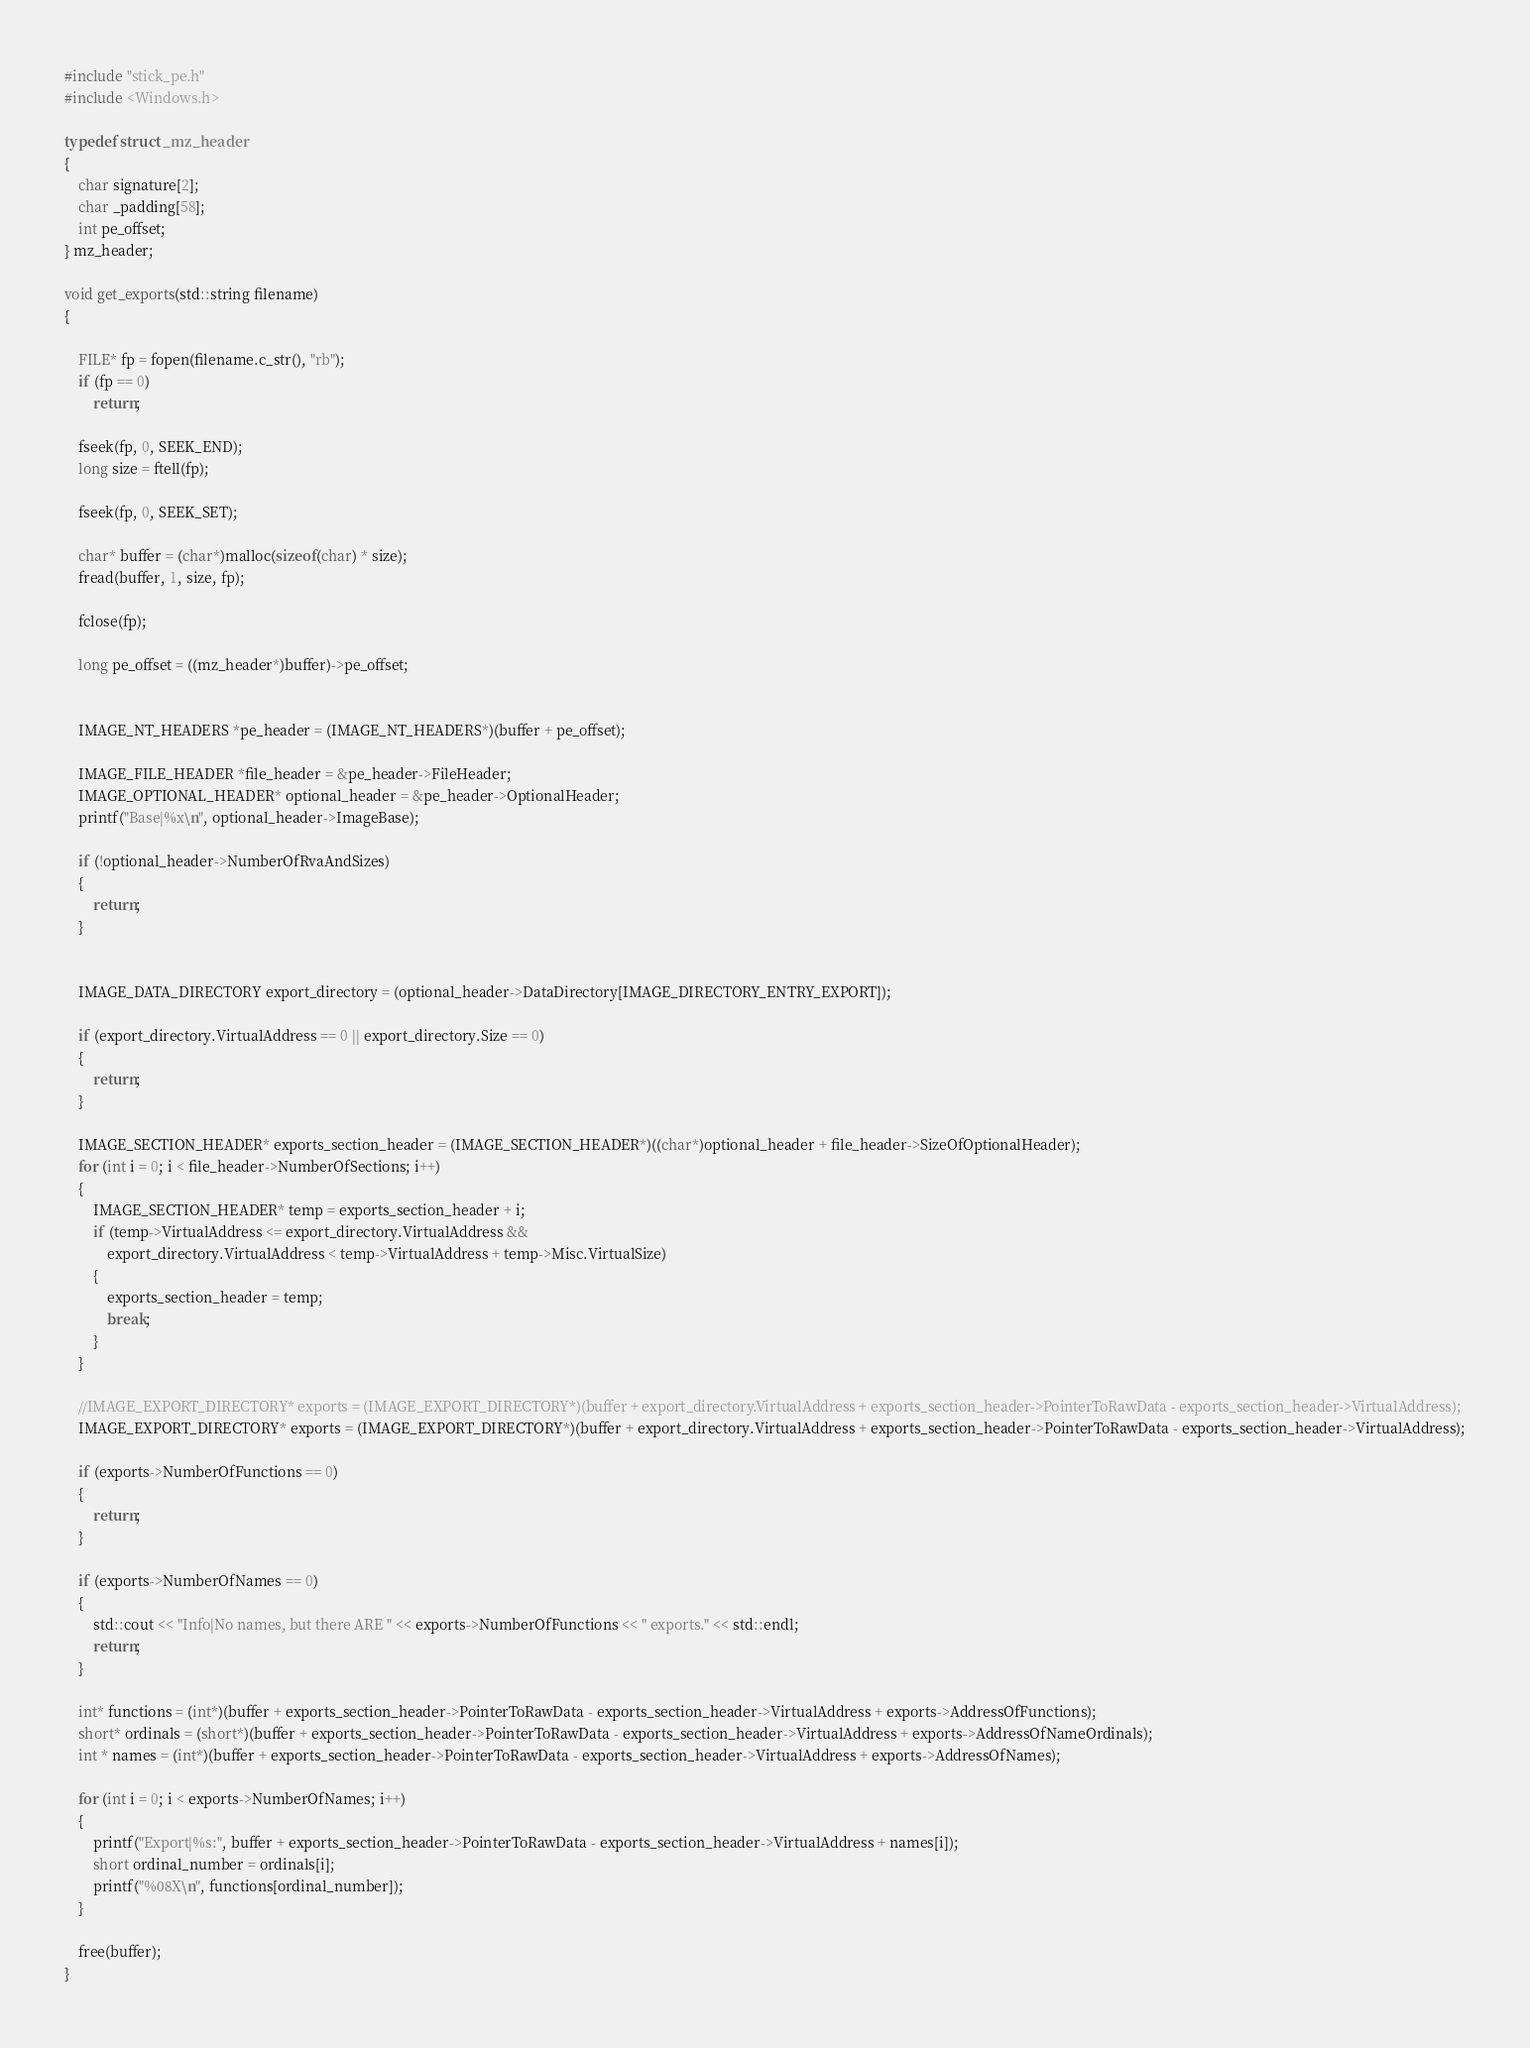<code> <loc_0><loc_0><loc_500><loc_500><_C++_>#include "stick_pe.h"
#include <Windows.h>

typedef struct _mz_header
{
    char signature[2];
    char _padding[58];
    int pe_offset;
} mz_header;

void get_exports(std::string filename)
{
    
    FILE* fp = fopen(filename.c_str(), "rb");
    if (fp == 0)
        return;

    fseek(fp, 0, SEEK_END);
    long size = ftell(fp);

    fseek(fp, 0, SEEK_SET);

    char* buffer = (char*)malloc(sizeof(char) * size);
    fread(buffer, 1, size, fp);

    fclose(fp);

    long pe_offset = ((mz_header*)buffer)->pe_offset;

    
    IMAGE_NT_HEADERS *pe_header = (IMAGE_NT_HEADERS*)(buffer + pe_offset);

    IMAGE_FILE_HEADER *file_header = &pe_header->FileHeader;
    IMAGE_OPTIONAL_HEADER* optional_header = &pe_header->OptionalHeader;
    printf("Base|%x\n", optional_header->ImageBase);

    if (!optional_header->NumberOfRvaAndSizes)
    {
        return;
    }

    
    IMAGE_DATA_DIRECTORY export_directory = (optional_header->DataDirectory[IMAGE_DIRECTORY_ENTRY_EXPORT]);

    if (export_directory.VirtualAddress == 0 || export_directory.Size == 0)
    {
        return;
    }
    
    IMAGE_SECTION_HEADER* exports_section_header = (IMAGE_SECTION_HEADER*)((char*)optional_header + file_header->SizeOfOptionalHeader);
    for (int i = 0; i < file_header->NumberOfSections; i++)
    {
        IMAGE_SECTION_HEADER* temp = exports_section_header + i;
        if (temp->VirtualAddress <= export_directory.VirtualAddress &&
            export_directory.VirtualAddress < temp->VirtualAddress + temp->Misc.VirtualSize)
        {
            exports_section_header = temp;
            break;
        }
    }

    //IMAGE_EXPORT_DIRECTORY* exports = (IMAGE_EXPORT_DIRECTORY*)(buffer + export_directory.VirtualAddress + exports_section_header->PointerToRawData - exports_section_header->VirtualAddress);
    IMAGE_EXPORT_DIRECTORY* exports = (IMAGE_EXPORT_DIRECTORY*)(buffer + export_directory.VirtualAddress + exports_section_header->PointerToRawData - exports_section_header->VirtualAddress);

    if (exports->NumberOfFunctions == 0)
    {
        return;
    }

    if (exports->NumberOfNames == 0)
    {
        std::cout << "Info|No names, but there ARE " << exports->NumberOfFunctions << " exports." << std::endl;
        return;
    }

    int* functions = (int*)(buffer + exports_section_header->PointerToRawData - exports_section_header->VirtualAddress + exports->AddressOfFunctions);
    short* ordinals = (short*)(buffer + exports_section_header->PointerToRawData - exports_section_header->VirtualAddress + exports->AddressOfNameOrdinals);
    int * names = (int*)(buffer + exports_section_header->PointerToRawData - exports_section_header->VirtualAddress + exports->AddressOfNames);

    for (int i = 0; i < exports->NumberOfNames; i++)
    {
        printf("Export|%s:", buffer + exports_section_header->PointerToRawData - exports_section_header->VirtualAddress + names[i]);
        short ordinal_number = ordinals[i];
        printf("%08X\n", functions[ordinal_number]);
    }

    free(buffer);
}</code> 